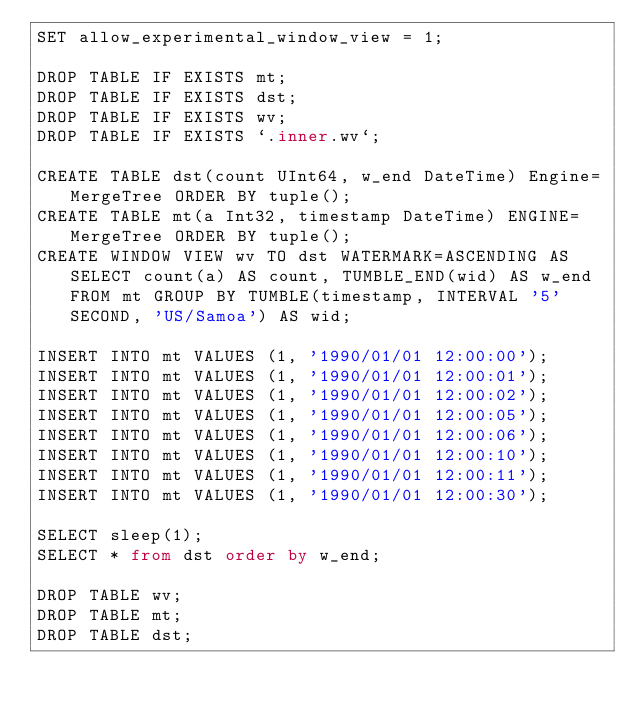<code> <loc_0><loc_0><loc_500><loc_500><_SQL_>SET allow_experimental_window_view = 1;

DROP TABLE IF EXISTS mt;
DROP TABLE IF EXISTS dst;
DROP TABLE IF EXISTS wv;
DROP TABLE IF EXISTS `.inner.wv`;

CREATE TABLE dst(count UInt64, w_end DateTime) Engine=MergeTree ORDER BY tuple();
CREATE TABLE mt(a Int32, timestamp DateTime) ENGINE=MergeTree ORDER BY tuple();
CREATE WINDOW VIEW wv TO dst WATERMARK=ASCENDING AS SELECT count(a) AS count, TUMBLE_END(wid) AS w_end FROM mt GROUP BY TUMBLE(timestamp, INTERVAL '5' SECOND, 'US/Samoa') AS wid;

INSERT INTO mt VALUES (1, '1990/01/01 12:00:00');
INSERT INTO mt VALUES (1, '1990/01/01 12:00:01');
INSERT INTO mt VALUES (1, '1990/01/01 12:00:02');
INSERT INTO mt VALUES (1, '1990/01/01 12:00:05');
INSERT INTO mt VALUES (1, '1990/01/01 12:00:06');
INSERT INTO mt VALUES (1, '1990/01/01 12:00:10');
INSERT INTO mt VALUES (1, '1990/01/01 12:00:11');
INSERT INTO mt VALUES (1, '1990/01/01 12:00:30');

SELECT sleep(1);
SELECT * from dst order by w_end;

DROP TABLE wv;
DROP TABLE mt;
DROP TABLE dst;
</code> 